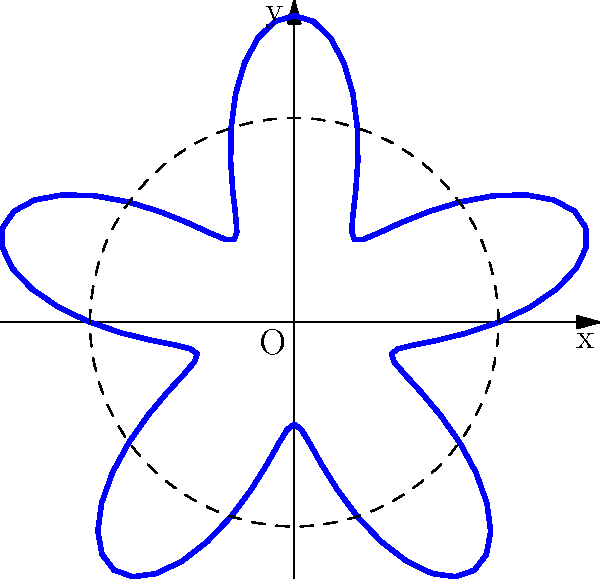In the context of plotting radial lens flares using polar coordinates, what mathematical function would best represent the flare pattern shown in the diagram, where the intensity varies periodically around a circular base? To understand the representation of the radial lens flare pattern, let's break it down step-by-step:

1. The base shape is circular, as indicated by the dashed circle in the diagram.

2. The flare pattern shows periodic variations around this circular base, with 5 distinct "peaks" or lobes.

3. In polar coordinates, we can represent this pattern using a function $r(\theta)$, where $r$ is the radius and $\theta$ is the angle.

4. The circular base suggests a constant term in the function, let's say 1.

5. The periodic variation suggests a sinusoidal function. Given that there are 5 lobes, we need a frequency of 5 in our sine function.

6. The amplitude of the variation appears to be about half the radius of the base circle.

7. Combining these observations, we can construct the function:

   $r(\theta) = 1 + 0.5 \sin(5\theta)$

8. This function represents:
   - A base radius of 1
   - Variations of ±0.5 around this base
   - 5 complete cycles as $\theta$ goes from 0 to $2\pi$

9. This type of function is commonly used in computer graphics to create star-like or flower-like patterns, which is ideal for representing lens flares in a stylized manner.
Answer: $r(\theta) = 1 + 0.5 \sin(5\theta)$ 